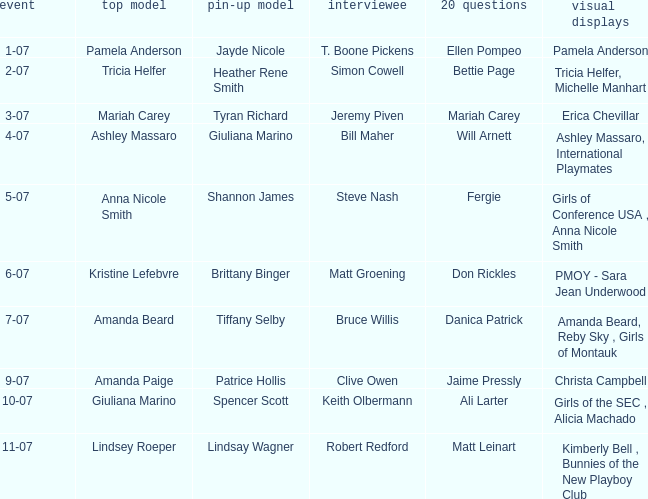List the pictorals from issues when lindsey roeper was the cover model. Kimberly Bell , Bunnies of the New Playboy Club. 